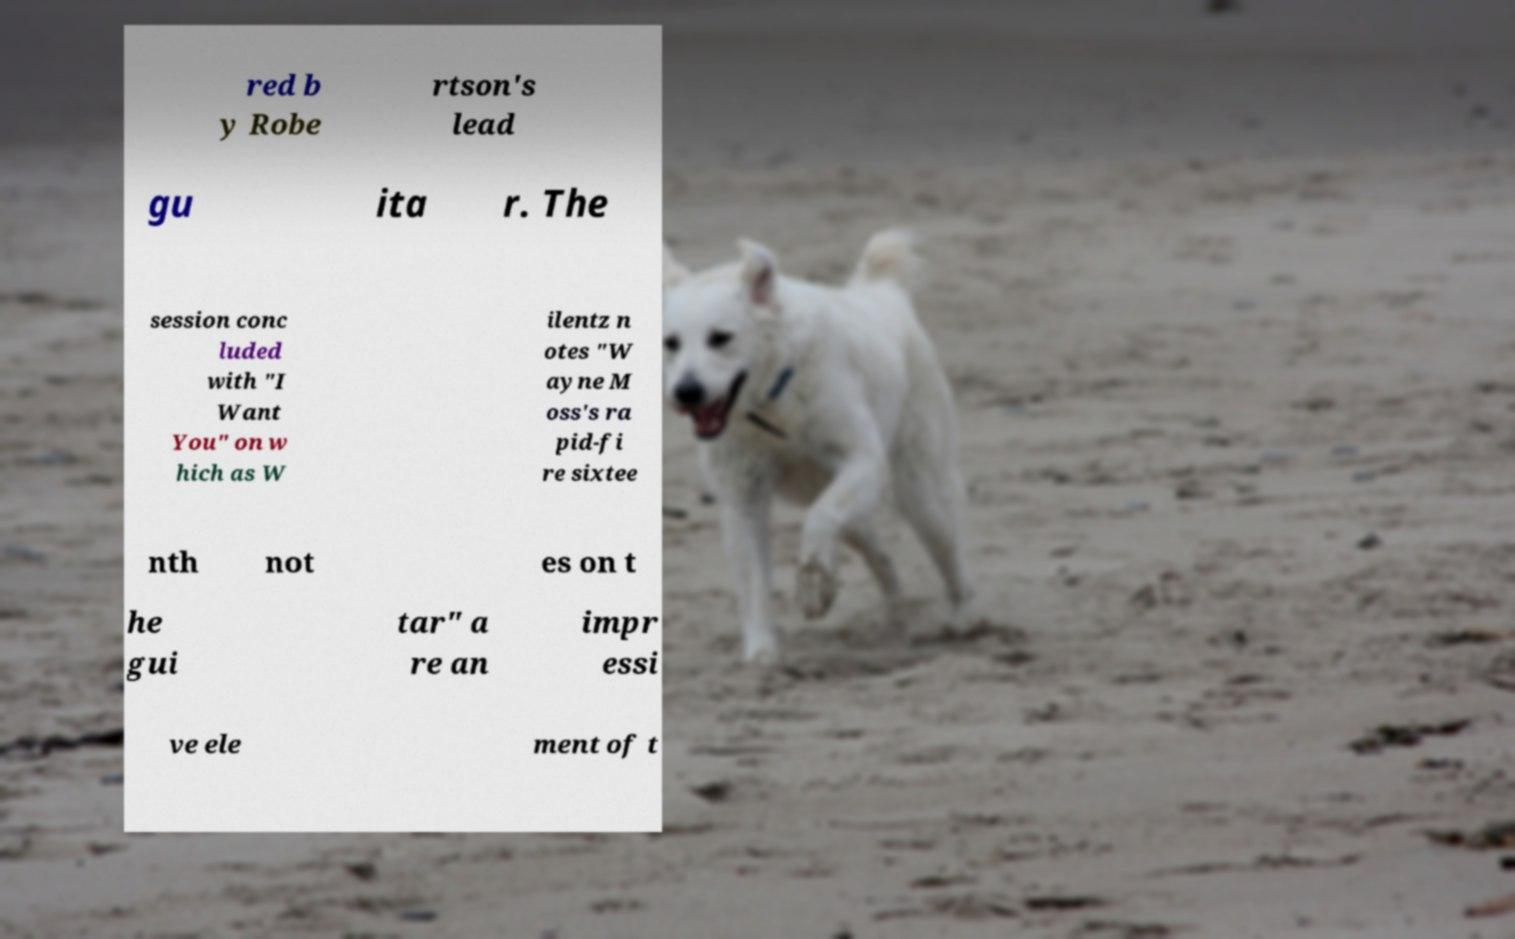What messages or text are displayed in this image? I need them in a readable, typed format. red b y Robe rtson's lead gu ita r. The session conc luded with "I Want You" on w hich as W ilentz n otes "W ayne M oss's ra pid-fi re sixtee nth not es on t he gui tar" a re an impr essi ve ele ment of t 